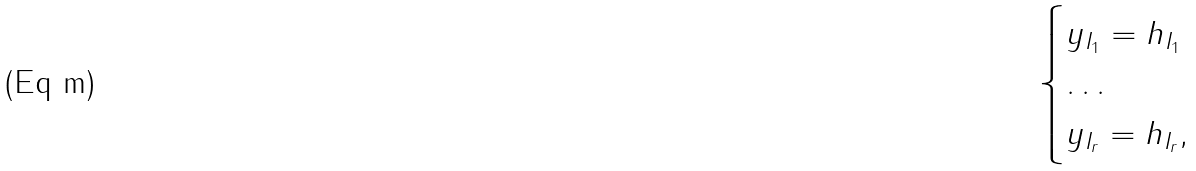<formula> <loc_0><loc_0><loc_500><loc_500>\begin{cases} y _ { I _ { 1 } } = h _ { I _ { 1 } } \\ \dots \\ y _ { I _ { r } } = h _ { I _ { r } } , \end{cases}</formula> 